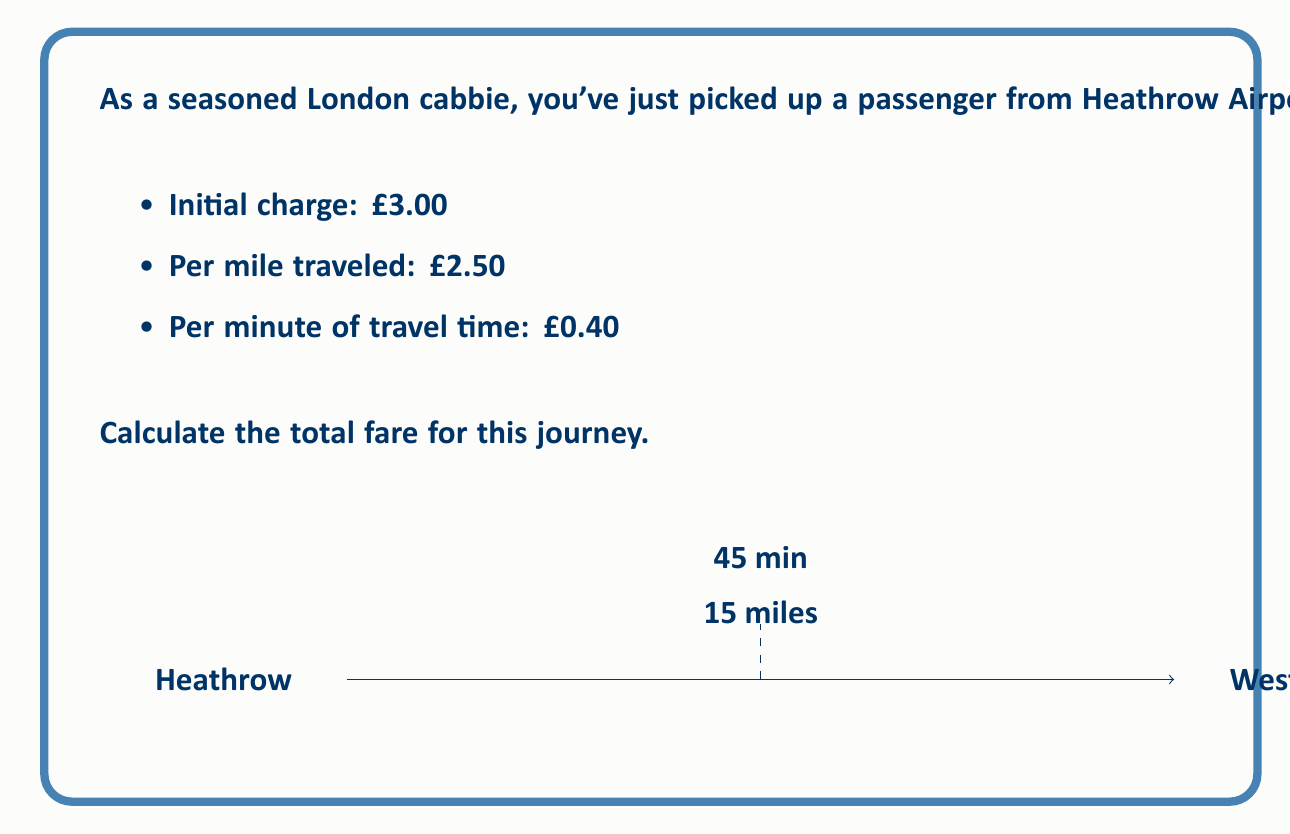Provide a solution to this math problem. Let's break down the fare calculation step-by-step:

1) Initial charge:
   $$\text{Initial charge} = £3.00$$

2) Distance charge:
   $$\text{Distance charge} = 15 \text{ miles} \times £2.50/\text{mile} = £37.50$$

3) Time charge:
   $$\text{Time charge} = 45 \text{ minutes} \times £0.40/\text{minute} = £18.00$$

4) Total fare:
   $$\begin{align}
   \text{Total fare} &= \text{Initial charge} + \text{Distance charge} + \text{Time charge} \\
   &= £3.00 + £37.50 + £18.00 \\
   &= £58.50
   \end{align}$$

Therefore, the total fare for the journey is £58.50.
Answer: £58.50 